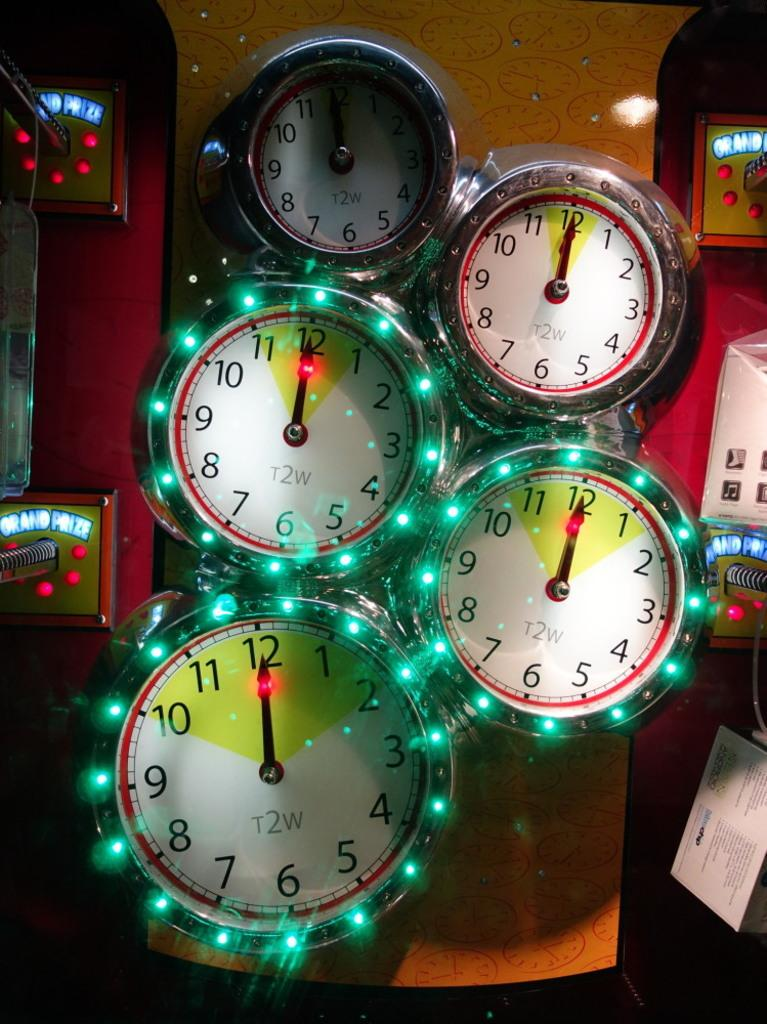What objects are present in the image? There are blocks and lights in the image. How are the blocks positioned in the image? The blocks are attached to an orange surface. What colors can be seen on the lights in the image? The lights have green, red, and blue colors. Is there a shelf holding the blocks in the image? There is no shelf present in the image; the blocks are attached to an orange surface. Is the party in full swing in the image? There is no indication of a party in the image, as it only features blocks and lights. 